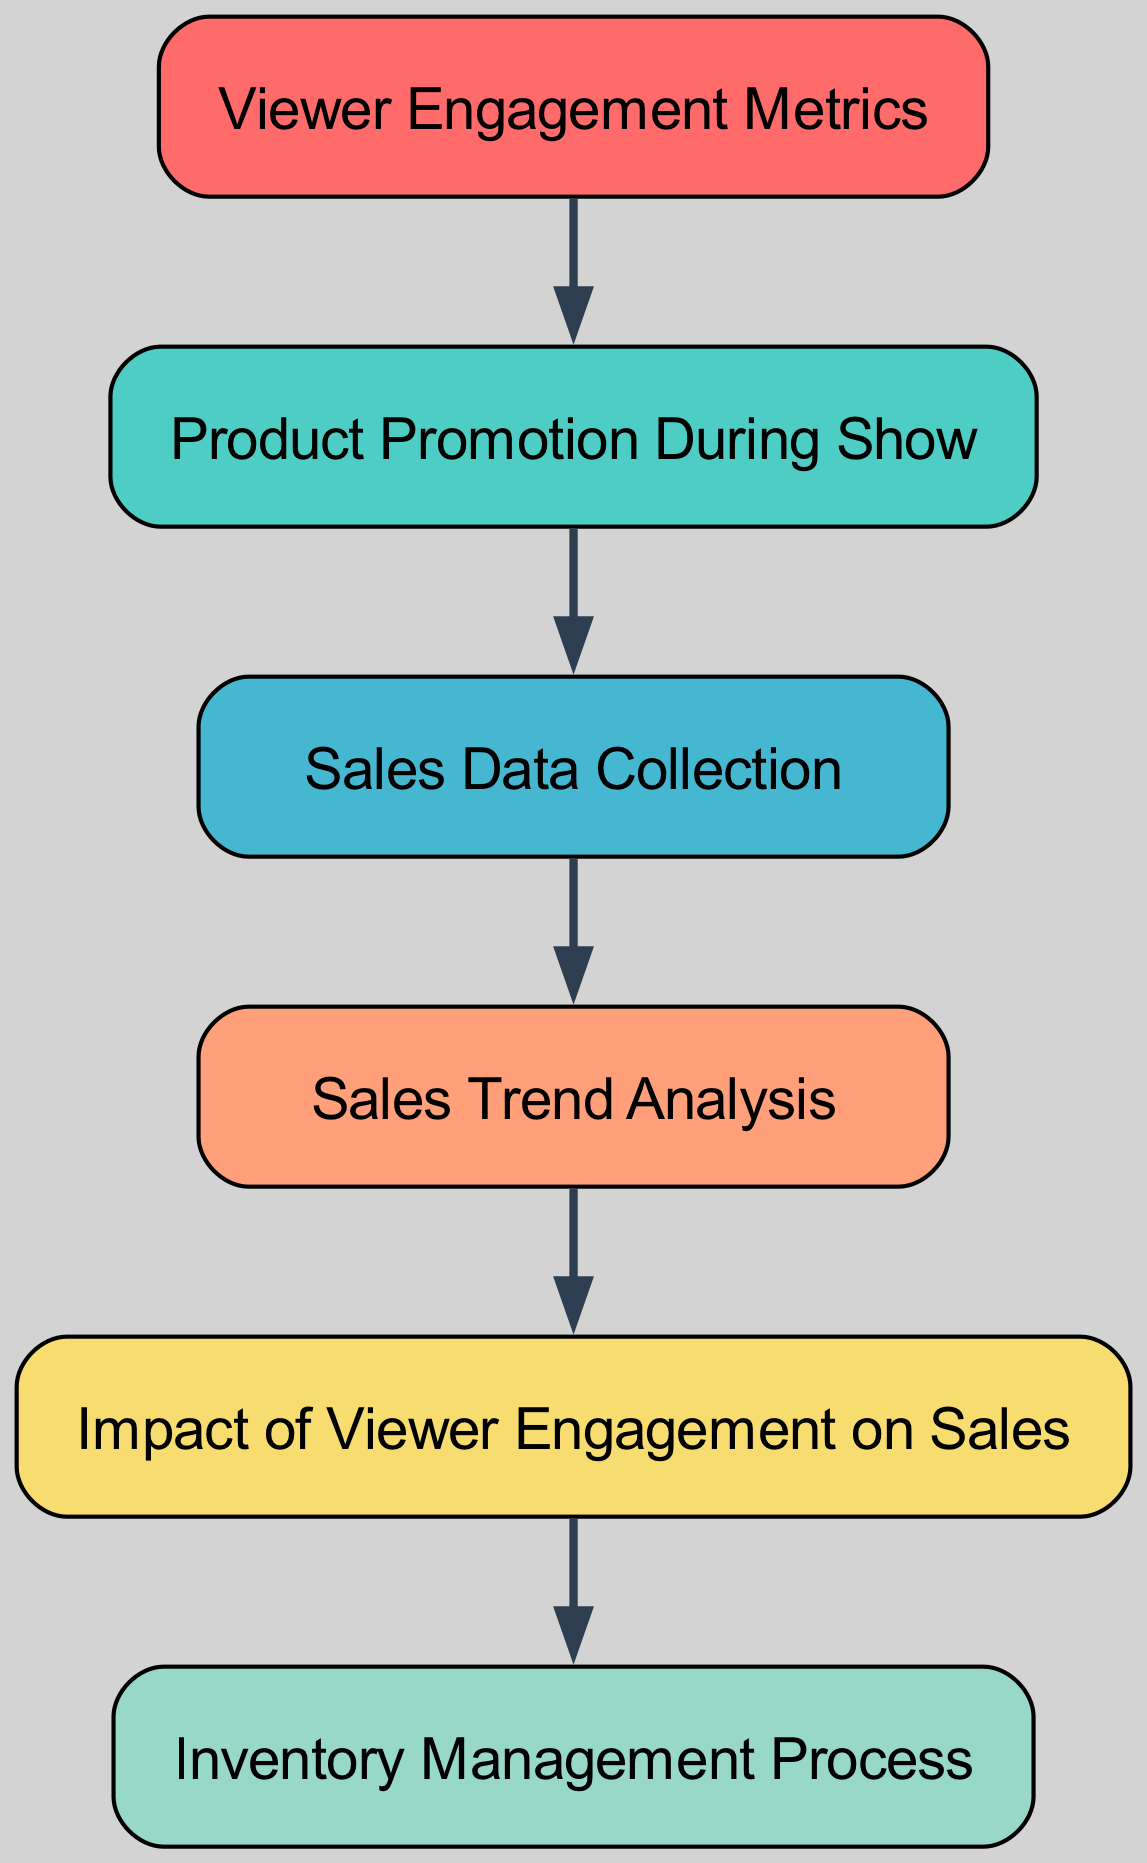What are the total number of nodes in the diagram? The diagram lists six unique nodes that represent different aspects of the sales tracking process, which can be counted directly in the nodes section of the data provided.
Answer: 6 What is the relationship between Viewer Engagement Metrics and Product Promotion? The diagram indicates a direct edge from "Viewer Engagement Metrics" to "Product Promotion," meaning that they are linked by influence or flow in the process of analyzing sales data.
Answer: Direct influence What follows Sales Data Collection in the process? Following the "Sales Data Collection" node, the next step in the diagram is "Sales Trend Analysis," which takes the collected sales data for further analysis.
Answer: Sales Trend Analysis What node is directly influenced by Sales Trend Analysis? The direct impact of "Sales Trend Analysis" is on the node "Impact of Viewer Engagement on Sales," which receives information from the trend analysis step in the process chain.
Answer: Impact of Viewer Engagement on Sales How many edges are present in the diagram? The diagram has five defined edges that illustrate the directional relationships between the nodes, connecting the steps in the sales tracking process.
Answer: 5 What is the last step in the sales tracking process? The final node in the sales tracking process, as depicted in the diagram, is "Inventory Management Process," which concludes the flow of actions after analyzing the sales impacts.
Answer: Inventory Management Process Which node connects Viewer Engagement Metrics and Inventory Management? The "Impact of Viewer Engagement on Sales" node serves as a connection point between "Viewer Engagement Metrics" and "Inventory Management Process," creating a link through the data flow.
Answer: Impact of Viewer Engagement on Sales What is the color of the Sales Data Collection node? The "Sales Data Collection" node adopts a specific fill color, namely #45B7D1, based on its position in the color palette established for the diagram, which can be verified by viewing the diagram’s color representation.
Answer: #45B7D1 What does the edge from Product Promotion to Sales Data signify? The edge from "Product Promotion" to "Sales Data Collection" signifies that product promotion activities during the show directly affect the collection of sales data afterward, indicating a clear causal relationship.
Answer: Direct effect 